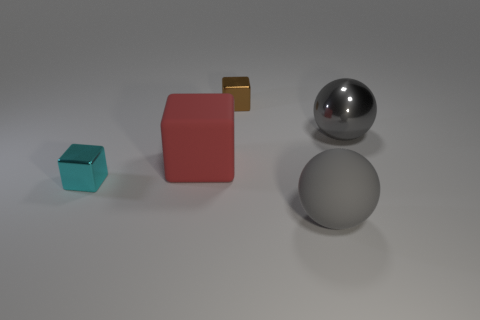Add 3 gray rubber things. How many objects exist? 8 Subtract all balls. How many objects are left? 3 Subtract 0 brown cylinders. How many objects are left? 5 Subtract all gray matte balls. Subtract all cyan shiny blocks. How many objects are left? 3 Add 5 tiny objects. How many tiny objects are left? 7 Add 1 big yellow matte cylinders. How many big yellow matte cylinders exist? 1 